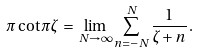Convert formula to latex. <formula><loc_0><loc_0><loc_500><loc_500>\pi \cot \pi \zeta \, = \, \lim _ { N \to \infty } \sum _ { n = - N } ^ { N } \frac { 1 } { \zeta + n } \, .</formula> 